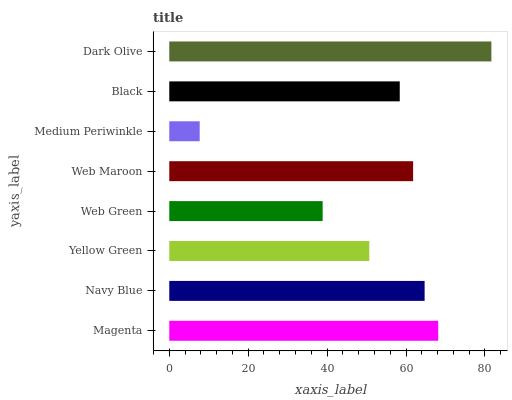Is Medium Periwinkle the minimum?
Answer yes or no. Yes. Is Dark Olive the maximum?
Answer yes or no. Yes. Is Navy Blue the minimum?
Answer yes or no. No. Is Navy Blue the maximum?
Answer yes or no. No. Is Magenta greater than Navy Blue?
Answer yes or no. Yes. Is Navy Blue less than Magenta?
Answer yes or no. Yes. Is Navy Blue greater than Magenta?
Answer yes or no. No. Is Magenta less than Navy Blue?
Answer yes or no. No. Is Web Maroon the high median?
Answer yes or no. Yes. Is Black the low median?
Answer yes or no. Yes. Is Black the high median?
Answer yes or no. No. Is Medium Periwinkle the low median?
Answer yes or no. No. 